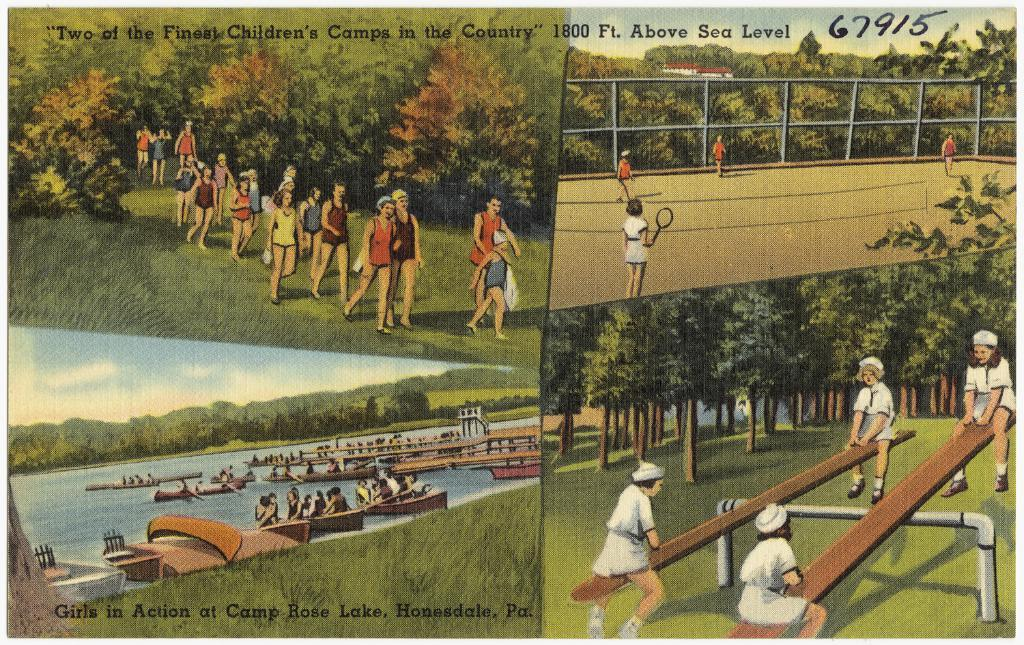<image>
Summarize the visual content of the image. Four pictures of a summer camp advertised as "Two of the Finest Children's Camps in the Country." 